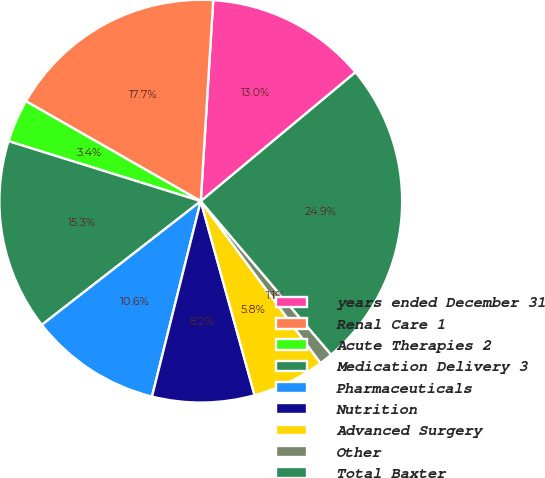Convert chart. <chart><loc_0><loc_0><loc_500><loc_500><pie_chart><fcel>years ended December 31<fcel>Renal Care 1<fcel>Acute Therapies 2<fcel>Medication Delivery 3<fcel>Pharmaceuticals<fcel>Nutrition<fcel>Advanced Surgery<fcel>Other<fcel>Total Baxter<nl><fcel>12.96%<fcel>17.72%<fcel>3.45%<fcel>15.34%<fcel>10.58%<fcel>8.2%<fcel>5.83%<fcel>1.07%<fcel>24.85%<nl></chart> 